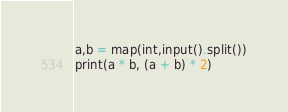Convert code to text. <code><loc_0><loc_0><loc_500><loc_500><_Python_>a,b = map(int,input().split())
print(a * b, (a + b) * 2)

</code> 